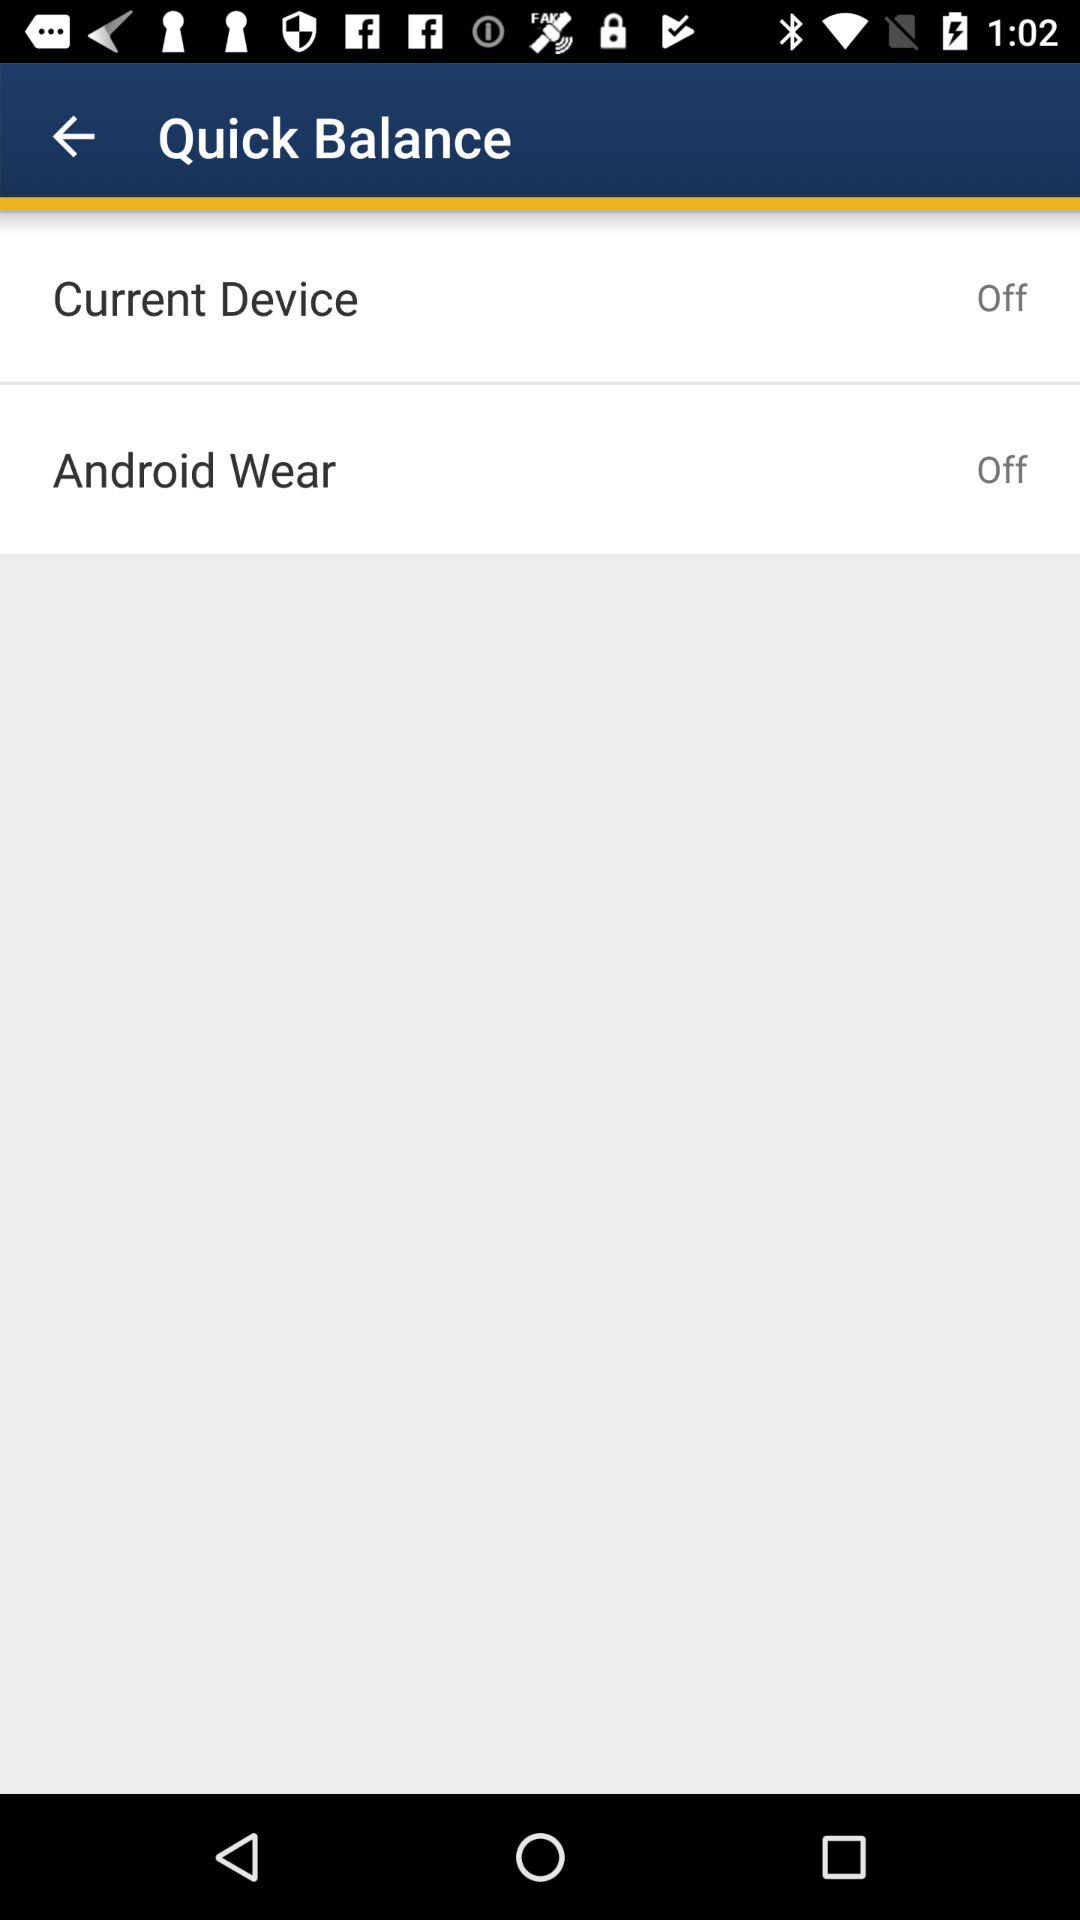How many devices are off?
Answer the question using a single word or phrase. 2 